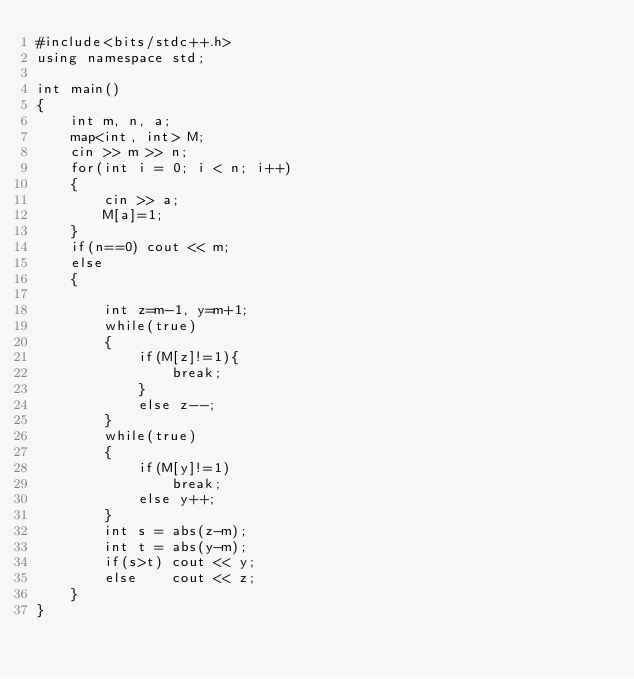Convert code to text. <code><loc_0><loc_0><loc_500><loc_500><_C++_>#include<bits/stdc++.h>
using namespace std;

int main()
{
    int m, n, a;
    map<int, int> M;
    cin >> m >> n;
    for(int i = 0; i < n; i++)
    {
        cin >> a;
        M[a]=1;
    }
    if(n==0) cout << m;
    else
    {

        int z=m-1, y=m+1;
        while(true)
        {
            if(M[z]!=1){
                break;
            }
            else z--;
        }
        while(true)
        {
            if(M[y]!=1)
                break;
            else y++;
        }
        int s = abs(z-m);
        int t = abs(y-m);
        if(s>t) cout << y;
        else    cout << z;
    }
}
</code> 